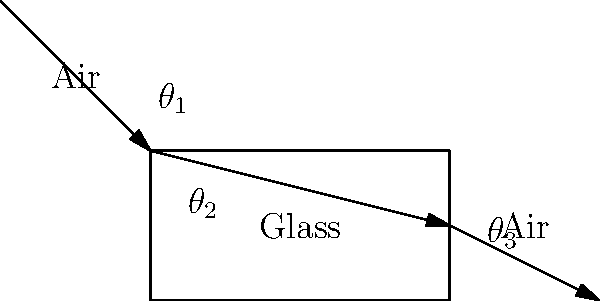In the diagram above, light passes through different mediums. If the refractive index of air is 1.0 and the refractive index of glass is 1.5, how would you explain the change in the light's path to someone who has spent time in a correctional facility and is now readjusting to society? Consider using analogies that might be relatable to their experiences. To explain this concept to someone readjusting to society after time in a correctional facility, we can break it down into relatable steps:

1. Light behavior analogy: Think of light as a person trying to navigate through different environments. Just as a person might change their path when moving from one type of surface to another (e.g., from concrete to grass), light changes its direction when moving between different materials.

2. Refractive index: This is like the "resistance" of the material. Air has a lower resistance (refractive index of 1.0) compared to glass (refractive index of 1.5). It's similar to how walking on a smooth floor is easier than walking through water.

3. Snell's Law: This law describes how light bends. In mathematical terms, it's written as:

   $$n_1 \sin(\theta_1) = n_2 \sin(\theta_2)$$

   where $n_1$ and $n_2$ are the refractive indices, and $\theta_1$ and $\theta_2$ are the angles of incidence and refraction.

4. Bending towards the normal: When light enters a material with a higher refractive index (like glass), it bends towards the normal (an imaginary line perpendicular to the surface). This is like slowing down and taking a more direct path when entering a more resistant medium.

5. Bending away from the normal: When light exits the glass and re-enters the air, it bends away from the normal. This is like speeding up and taking a wider path when entering a less resistant medium.

6. Critical angle and total internal reflection: If the angle of incidence is too large when light tries to exit a material with a higher refractive index, it can be completely reflected back. This is like trying to leave a restricted area at too sharp an angle and being forced back.

By understanding these principles, we can see how light adapts to its environment, much like how individuals must adapt to different situations in society. The key is to understand the "rules" of each environment and adjust accordingly.
Answer: Light bends towards the normal when entering a denser medium (air to glass) and away when exiting to a less dense medium (glass to air), analogous to adapting to different social environments. 